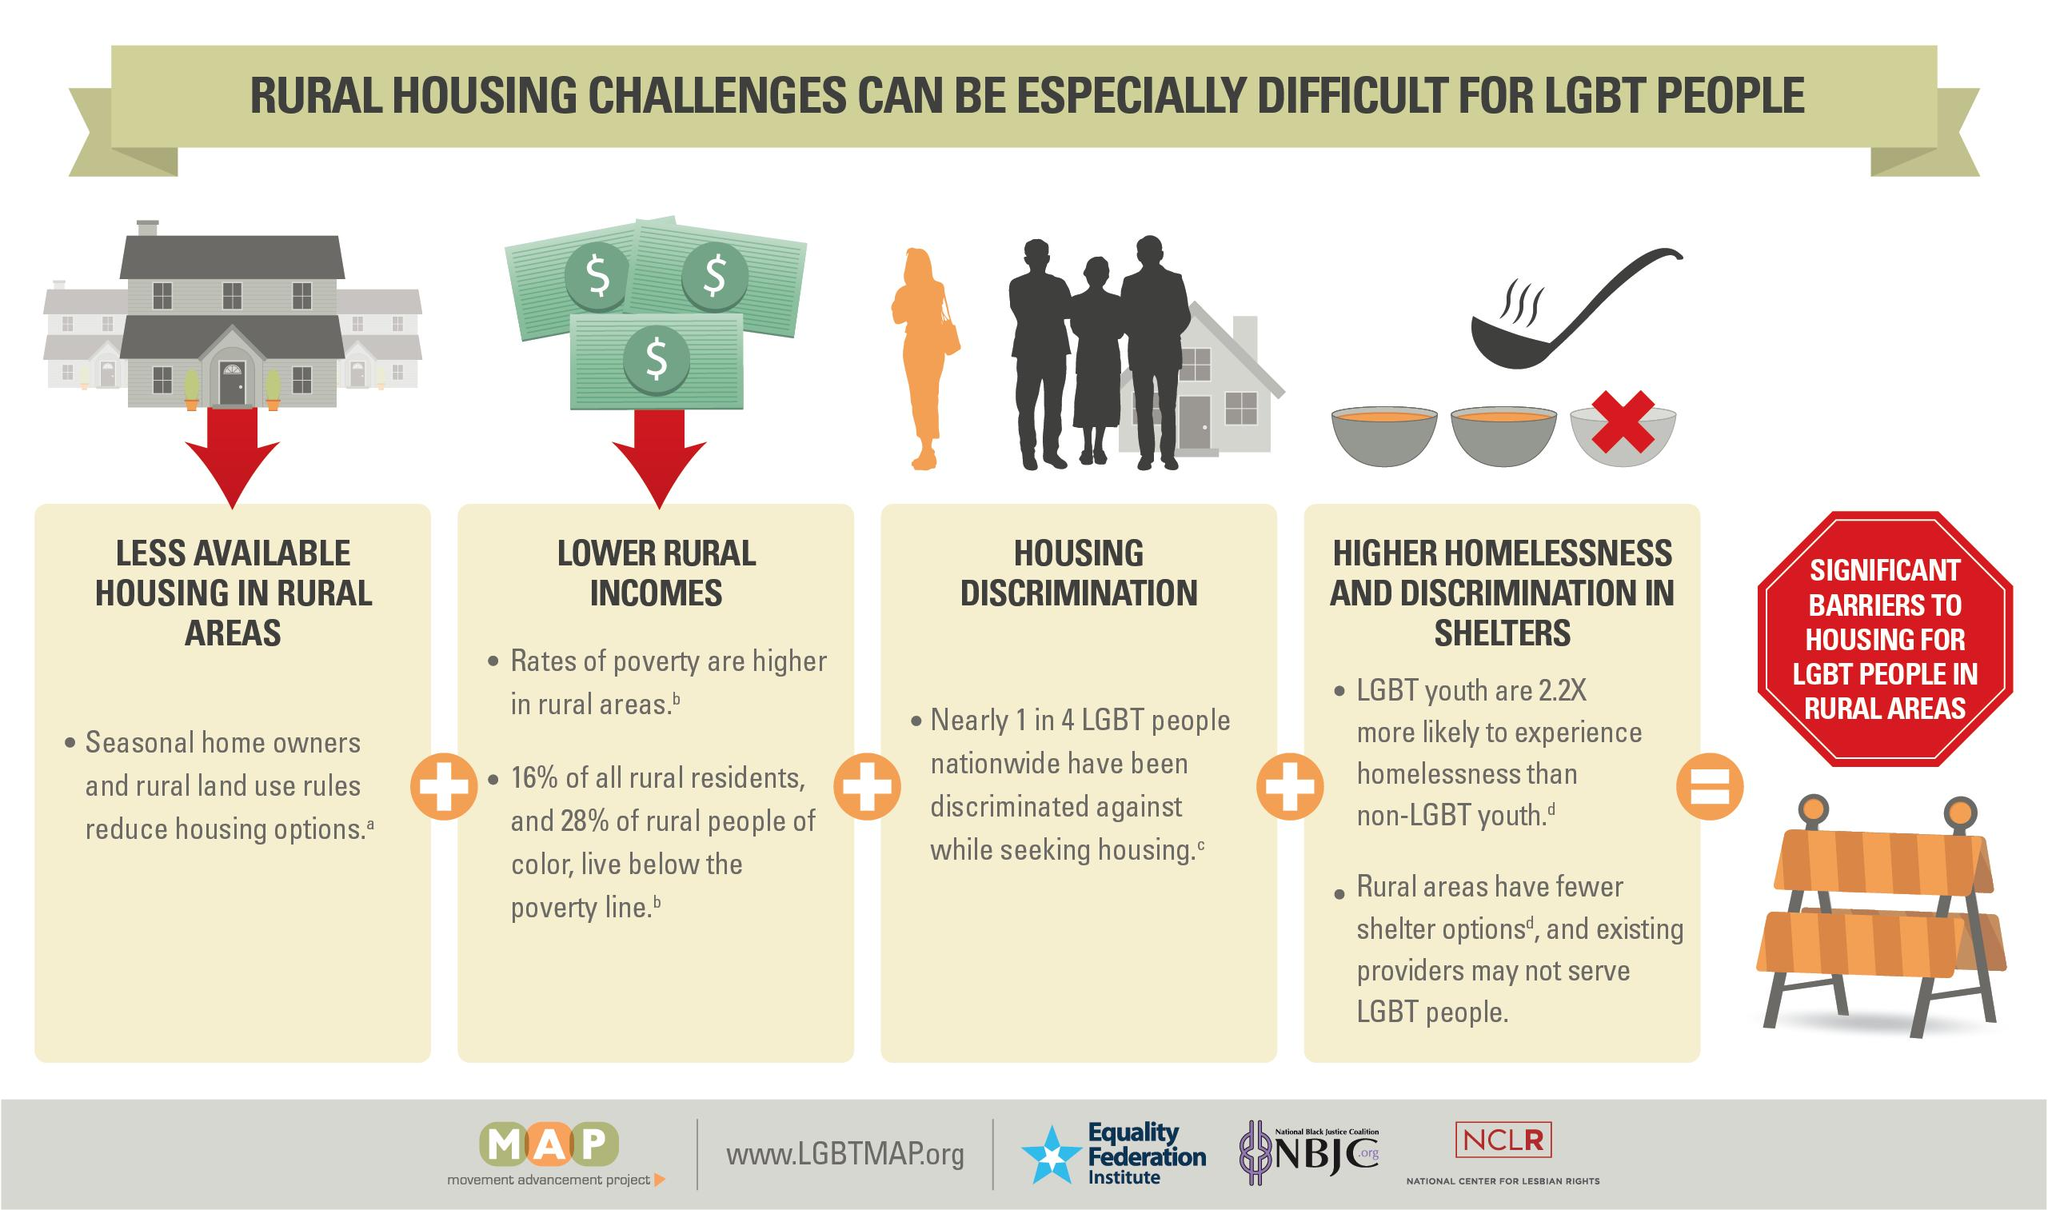List a handful of essential elements in this visual. There are 4 rural housing challenges. 